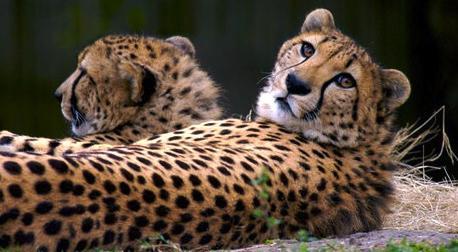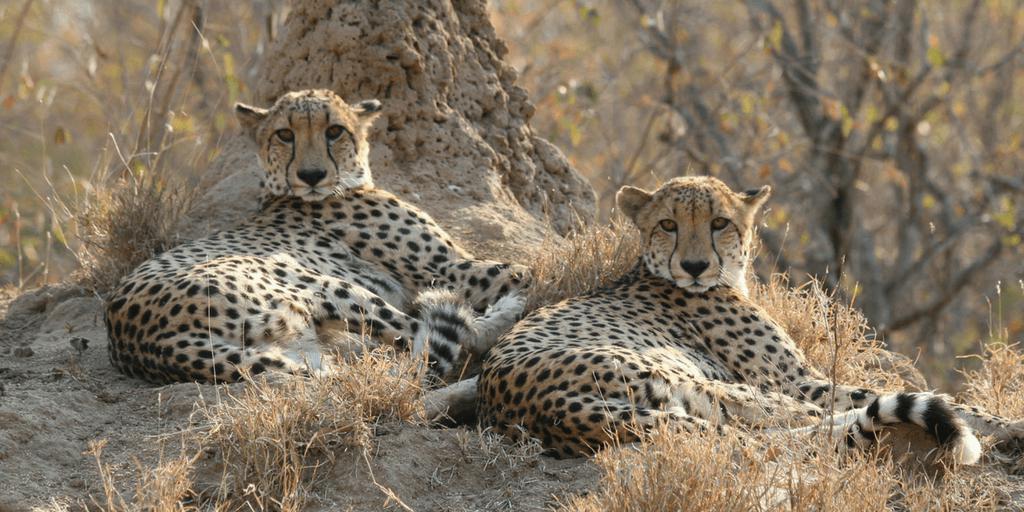The first image is the image on the left, the second image is the image on the right. For the images shown, is this caption "The left image contains exactly two cheetahs." true? Answer yes or no. Yes. The first image is the image on the left, the second image is the image on the right. Examine the images to the left and right. Is the description "In two images two cheetahs are lying next to one another in the brown patchy grass." accurate? Answer yes or no. Yes. 